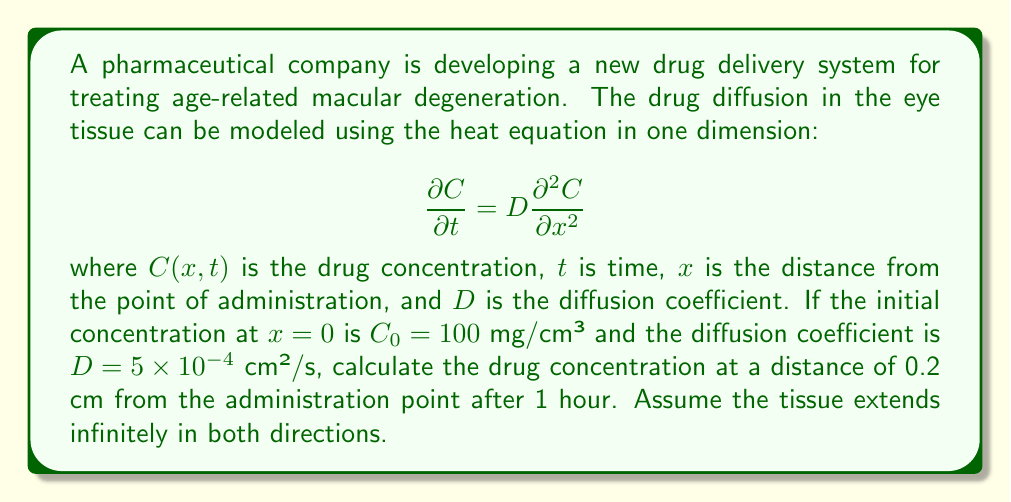Show me your answer to this math problem. To solve this problem, we can use the fundamental solution of the heat equation for an instantaneous point source in an infinite medium. The solution is given by:

$$C(x,t) = \frac{C_0}{\sqrt{4\pi Dt}} \exp\left(-\frac{x^2}{4Dt}\right)$$

Let's substitute the given values:

1. $C_0 = 100$ mg/cm³
2. $D = 5 \times 10^{-4}$ cm²/s
3. $x = 0.2$ cm
4. $t = 1$ hour = 3600 seconds

First, let's calculate $4Dt$:

$$4Dt = 4 \times (5 \times 10^{-4}) \times 3600 = 7.2 \text{ cm²}$$

Now, we can substitute these values into the solution equation:

$$\begin{align*}
C(0.2, 3600) &= \frac{100}{\sqrt{4\pi \times 5 \times 10^{-4} \times 3600}} \exp\left(-\frac{0.2^2}{7.2}\right) \\[10pt]
&= \frac{100}{\sqrt{7.2\pi}} \exp\left(-\frac{0.04}{7.2}\right) \\[10pt]
&= \frac{100}{\sqrt{22.62}} \exp(-0.00556) \\[10pt]
&= 21.03 \times 0.9945 \\[10pt]
&= 20.91 \text{ mg/cm³}
\end{align*}$$

Therefore, the drug concentration at a distance of 0.2 cm from the administration point after 1 hour is approximately 20.91 mg/cm³.
Answer: 20.91 mg/cm³ 